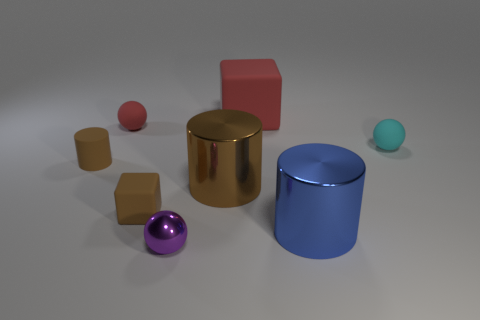Add 1 purple metallic objects. How many objects exist? 9 Subtract all cubes. How many objects are left? 6 Add 1 cyan rubber cylinders. How many cyan rubber cylinders exist? 1 Subtract 0 yellow spheres. How many objects are left? 8 Subtract all large purple cylinders. Subtract all red rubber things. How many objects are left? 6 Add 5 shiny objects. How many shiny objects are left? 8 